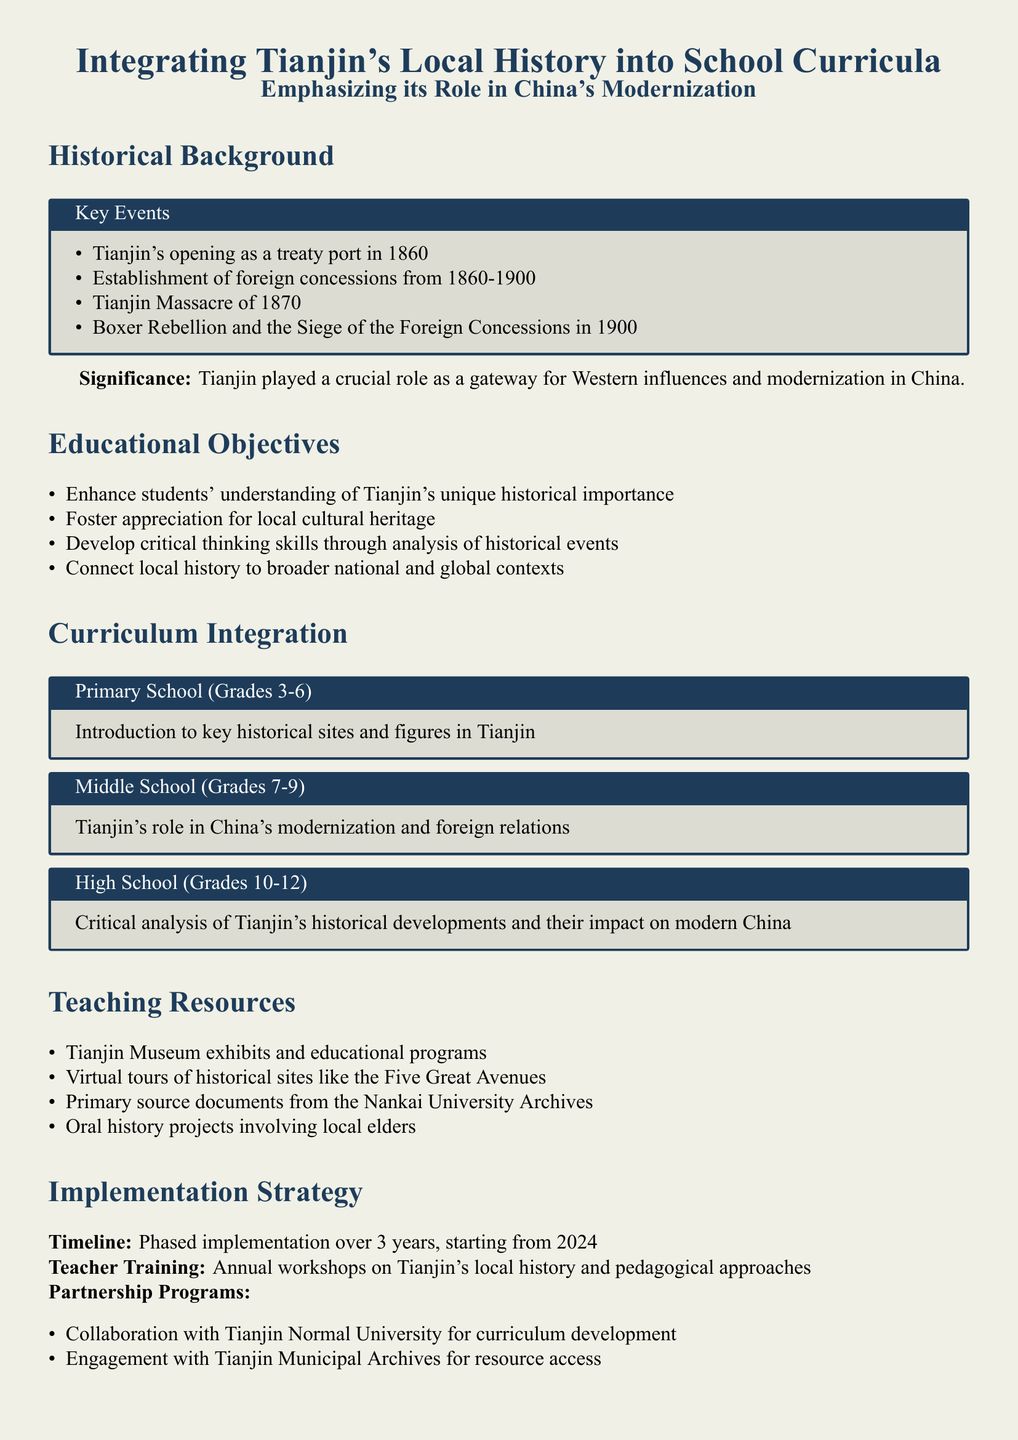what year did Tianjin open as a treaty port? The document states that Tianjin's opening as a treaty port occurred in 1860.
Answer: 1860 what is one educational objective listed in the document? The document lists multiple objectives, including enhancing students' understanding of Tianjin's unique historical importance.
Answer: Enhance students' understanding of Tianjin's unique historical importance how long is the phased implementation timeline mentioned in the document? The document specifies a timeline of three years for phased implementation starting from 2024.
Answer: 3 years which historical event involved a siege in 1900? The document mentions the Boxer Rebellion and the Siege of the Foreign Concessions as a significant event in 1900.
Answer: Boxer Rebellion what grade level is focused on critical analysis of Tianjin's historical developments? According to the document, high school students in grades 10-12 are focused on critical analysis of Tianjin's historical developments.
Answer: Grades 10-12 what is one resource mentioned for teaching? The document lists the Tianjin Museum exhibits and educational programs as a teaching resource.
Answer: Tianjin Museum exhibits and educational programs who will be involved in curriculum development? The document states that there will be a collaboration with Tianjin Normal University for curriculum development.
Answer: Tianjin Normal University what method is used for evaluating students' historical knowledge? The document indicates that annual student surveys will be utilized to assess local historical knowledge.
Answer: Annual student surveys 